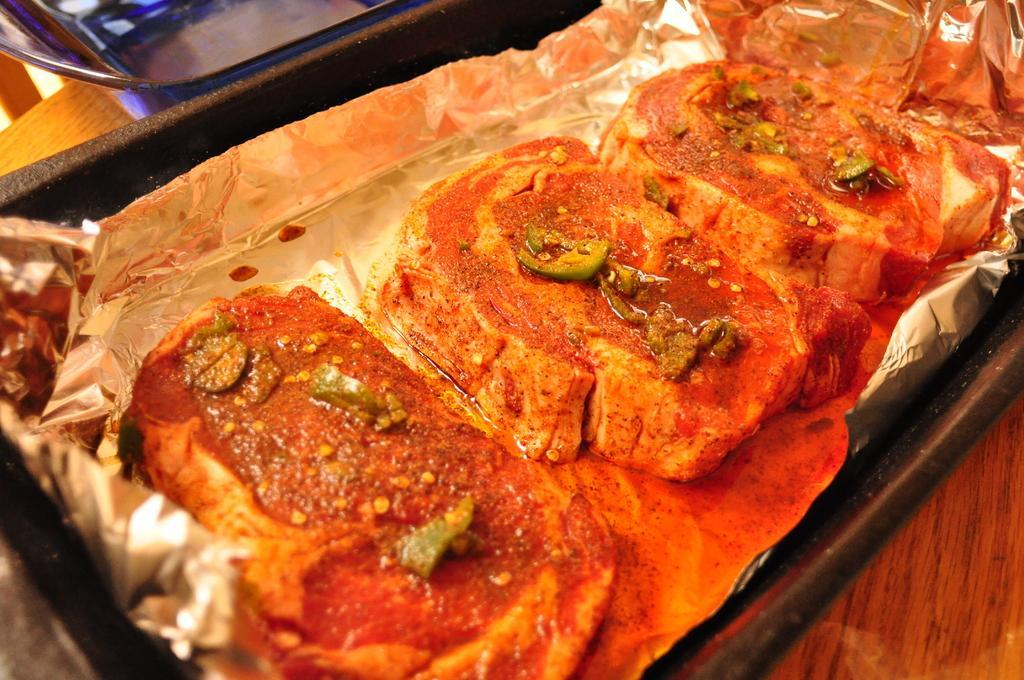How would you summarize this image in a sentence or two? In this picture we can see food items, aluminium foil in a tray and this tray is placed on the table and in the background we can see an object. 